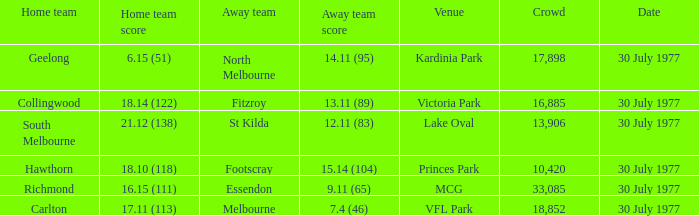Who represents the home squad when the opposing team's score is Richmond. 